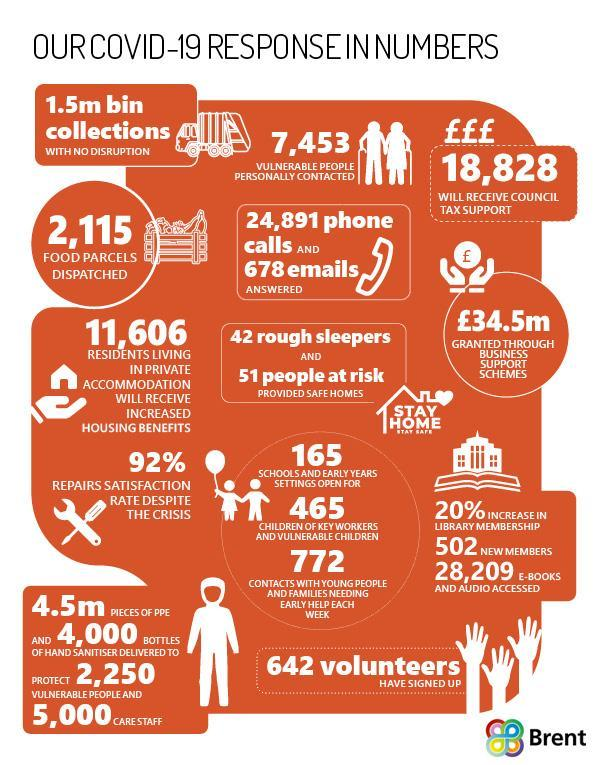What is the number of food parcels dispatched as a part of Brent's Covid-19 mission?
Answer the question with a short phrase. 2,115 How many rough sleepers were provided safe homes as a part of Brent's Covid-19 mission? 42 How many volunteers are dedicated to work in Brent's Covid-19 mission? 642 How many PPE kits were delivered to protect the vulnerable people & CARE staffs through Brent during the COVID-19 pandemic? 4.5m How many new library memberships were added during the COVID-19 pandemic? 502 How many residents living in private accommodation will receive increase housing benefits as a part of Brent's Covid-19 mission? 11,606 How much is the financial assistance offered (in pounds) for Council tax support by Brent? 18,828 How much is the fund granted through business support schemes through Brent? £34.5m How many vulnerable people were personally contacted as a part of Brent's Covid-19 mission? 7,453 